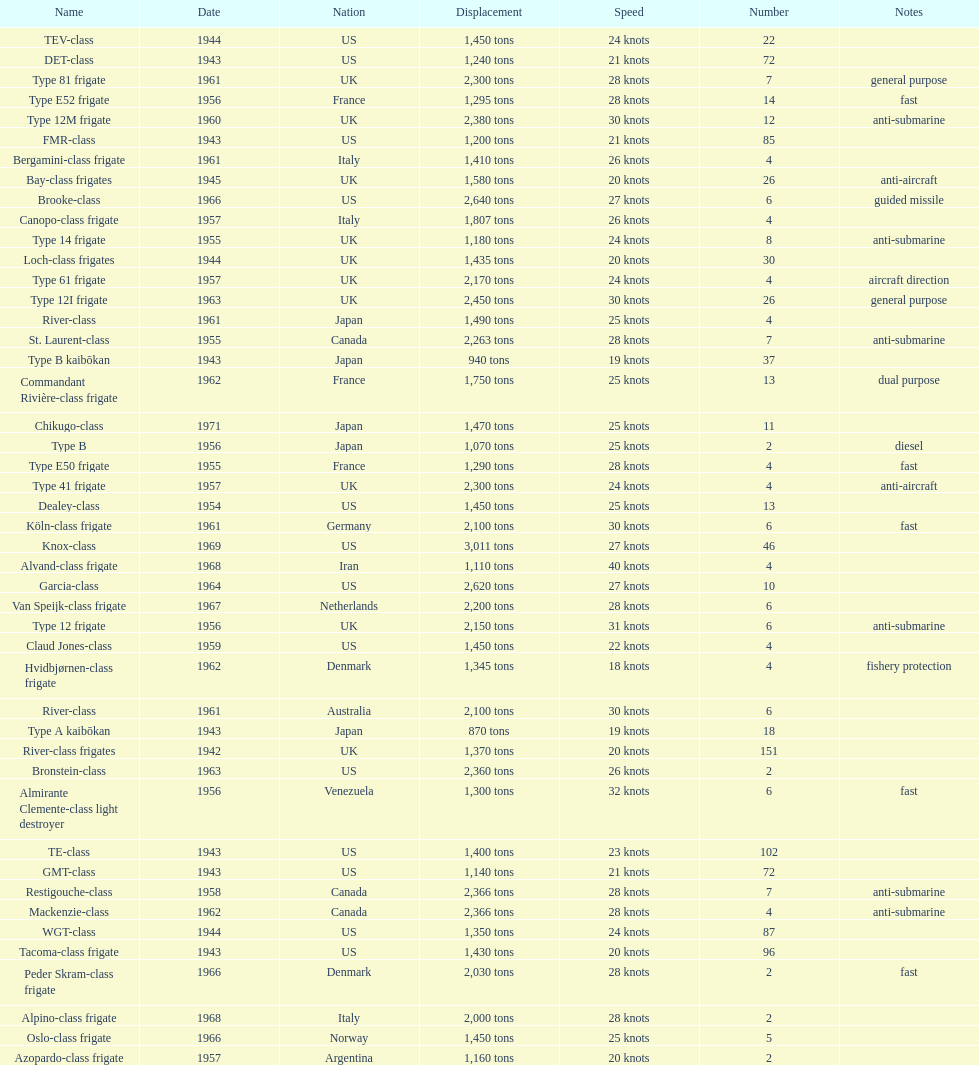How many consecutive escorts were in 1943? 7. 